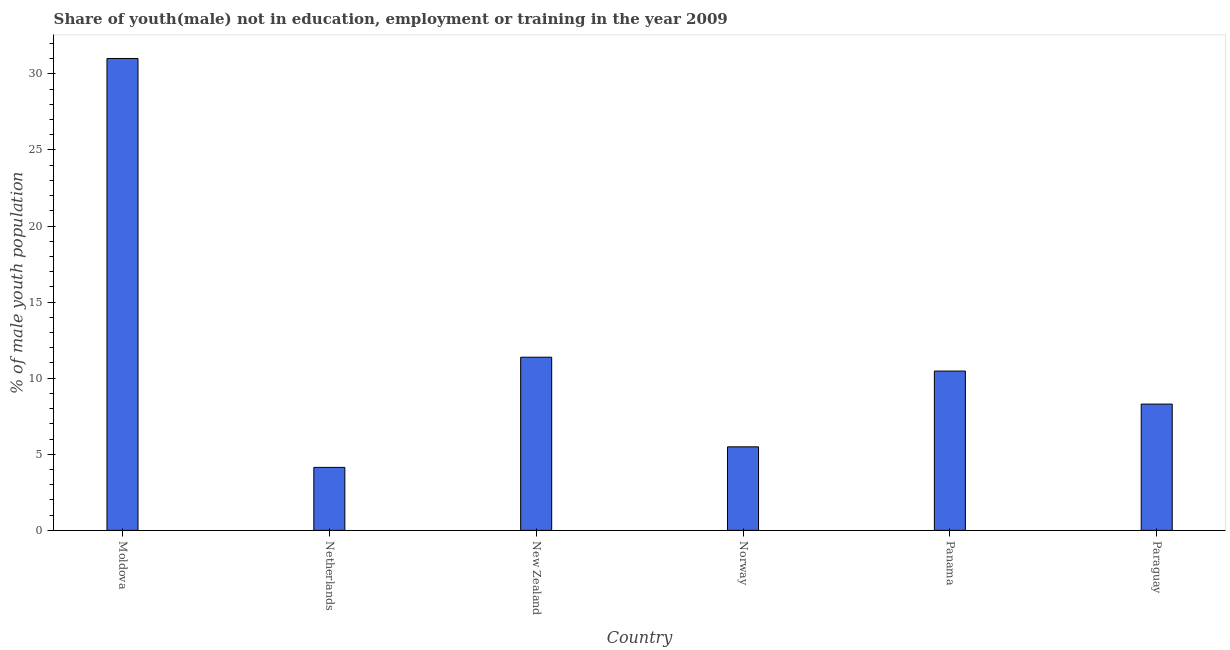Does the graph contain any zero values?
Ensure brevity in your answer.  No. What is the title of the graph?
Offer a terse response. Share of youth(male) not in education, employment or training in the year 2009. What is the label or title of the X-axis?
Offer a very short reply. Country. What is the label or title of the Y-axis?
Offer a terse response. % of male youth population. What is the unemployed male youth population in New Zealand?
Make the answer very short. 11.38. Across all countries, what is the maximum unemployed male youth population?
Offer a terse response. 31.01. Across all countries, what is the minimum unemployed male youth population?
Make the answer very short. 4.14. In which country was the unemployed male youth population maximum?
Your response must be concise. Moldova. In which country was the unemployed male youth population minimum?
Give a very brief answer. Netherlands. What is the sum of the unemployed male youth population?
Offer a terse response. 70.79. What is the difference between the unemployed male youth population in Moldova and Netherlands?
Offer a terse response. 26.87. What is the average unemployed male youth population per country?
Your response must be concise. 11.8. What is the median unemployed male youth population?
Offer a very short reply. 9.39. What is the ratio of the unemployed male youth population in Netherlands to that in New Zealand?
Keep it short and to the point. 0.36. What is the difference between the highest and the second highest unemployed male youth population?
Your response must be concise. 19.63. What is the difference between the highest and the lowest unemployed male youth population?
Provide a succinct answer. 26.87. How many bars are there?
Your response must be concise. 6. Are the values on the major ticks of Y-axis written in scientific E-notation?
Your response must be concise. No. What is the % of male youth population in Moldova?
Provide a succinct answer. 31.01. What is the % of male youth population of Netherlands?
Your answer should be compact. 4.14. What is the % of male youth population in New Zealand?
Make the answer very short. 11.38. What is the % of male youth population of Norway?
Your answer should be very brief. 5.49. What is the % of male youth population in Panama?
Offer a terse response. 10.47. What is the % of male youth population of Paraguay?
Offer a terse response. 8.3. What is the difference between the % of male youth population in Moldova and Netherlands?
Make the answer very short. 26.87. What is the difference between the % of male youth population in Moldova and New Zealand?
Offer a terse response. 19.63. What is the difference between the % of male youth population in Moldova and Norway?
Give a very brief answer. 25.52. What is the difference between the % of male youth population in Moldova and Panama?
Make the answer very short. 20.54. What is the difference between the % of male youth population in Moldova and Paraguay?
Ensure brevity in your answer.  22.71. What is the difference between the % of male youth population in Netherlands and New Zealand?
Offer a terse response. -7.24. What is the difference between the % of male youth population in Netherlands and Norway?
Provide a succinct answer. -1.35. What is the difference between the % of male youth population in Netherlands and Panama?
Ensure brevity in your answer.  -6.33. What is the difference between the % of male youth population in Netherlands and Paraguay?
Your response must be concise. -4.16. What is the difference between the % of male youth population in New Zealand and Norway?
Give a very brief answer. 5.89. What is the difference between the % of male youth population in New Zealand and Panama?
Give a very brief answer. 0.91. What is the difference between the % of male youth population in New Zealand and Paraguay?
Offer a very short reply. 3.08. What is the difference between the % of male youth population in Norway and Panama?
Keep it short and to the point. -4.98. What is the difference between the % of male youth population in Norway and Paraguay?
Ensure brevity in your answer.  -2.81. What is the difference between the % of male youth population in Panama and Paraguay?
Your answer should be very brief. 2.17. What is the ratio of the % of male youth population in Moldova to that in Netherlands?
Your answer should be very brief. 7.49. What is the ratio of the % of male youth population in Moldova to that in New Zealand?
Keep it short and to the point. 2.73. What is the ratio of the % of male youth population in Moldova to that in Norway?
Offer a terse response. 5.65. What is the ratio of the % of male youth population in Moldova to that in Panama?
Keep it short and to the point. 2.96. What is the ratio of the % of male youth population in Moldova to that in Paraguay?
Ensure brevity in your answer.  3.74. What is the ratio of the % of male youth population in Netherlands to that in New Zealand?
Make the answer very short. 0.36. What is the ratio of the % of male youth population in Netherlands to that in Norway?
Provide a short and direct response. 0.75. What is the ratio of the % of male youth population in Netherlands to that in Panama?
Your answer should be compact. 0.4. What is the ratio of the % of male youth population in Netherlands to that in Paraguay?
Your answer should be very brief. 0.5. What is the ratio of the % of male youth population in New Zealand to that in Norway?
Your response must be concise. 2.07. What is the ratio of the % of male youth population in New Zealand to that in Panama?
Keep it short and to the point. 1.09. What is the ratio of the % of male youth population in New Zealand to that in Paraguay?
Your answer should be very brief. 1.37. What is the ratio of the % of male youth population in Norway to that in Panama?
Provide a succinct answer. 0.52. What is the ratio of the % of male youth population in Norway to that in Paraguay?
Provide a succinct answer. 0.66. What is the ratio of the % of male youth population in Panama to that in Paraguay?
Make the answer very short. 1.26. 